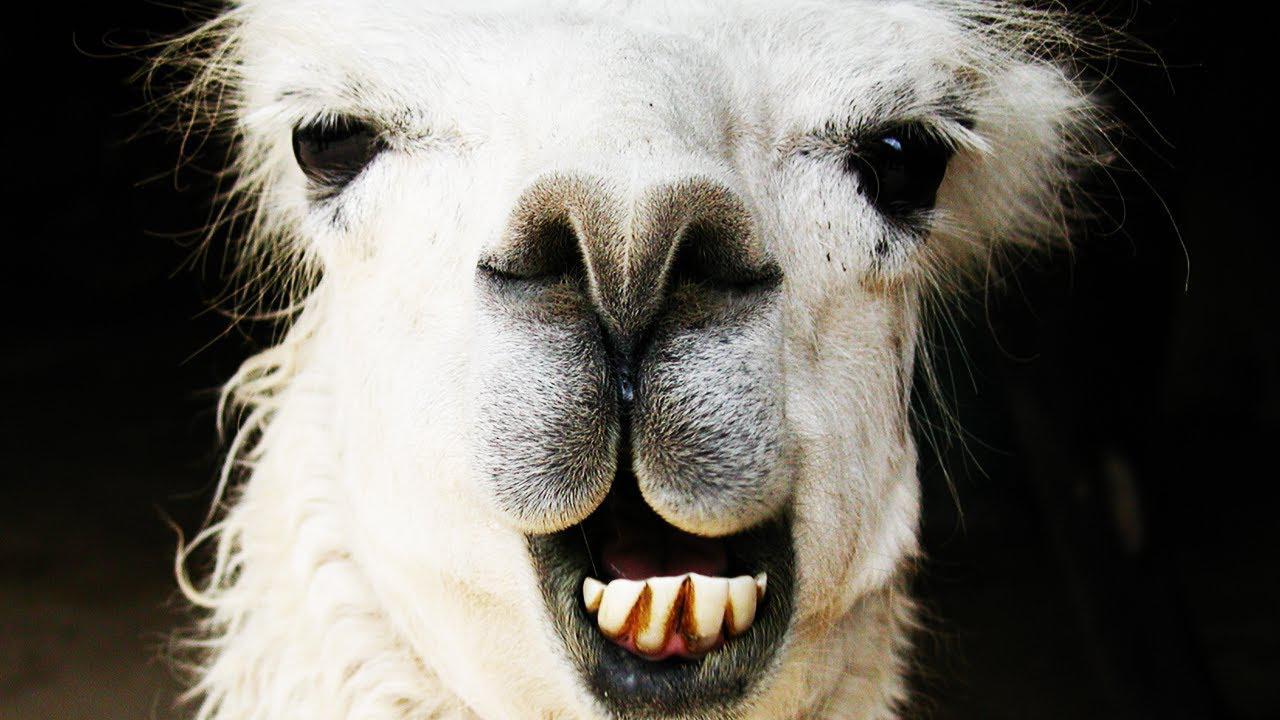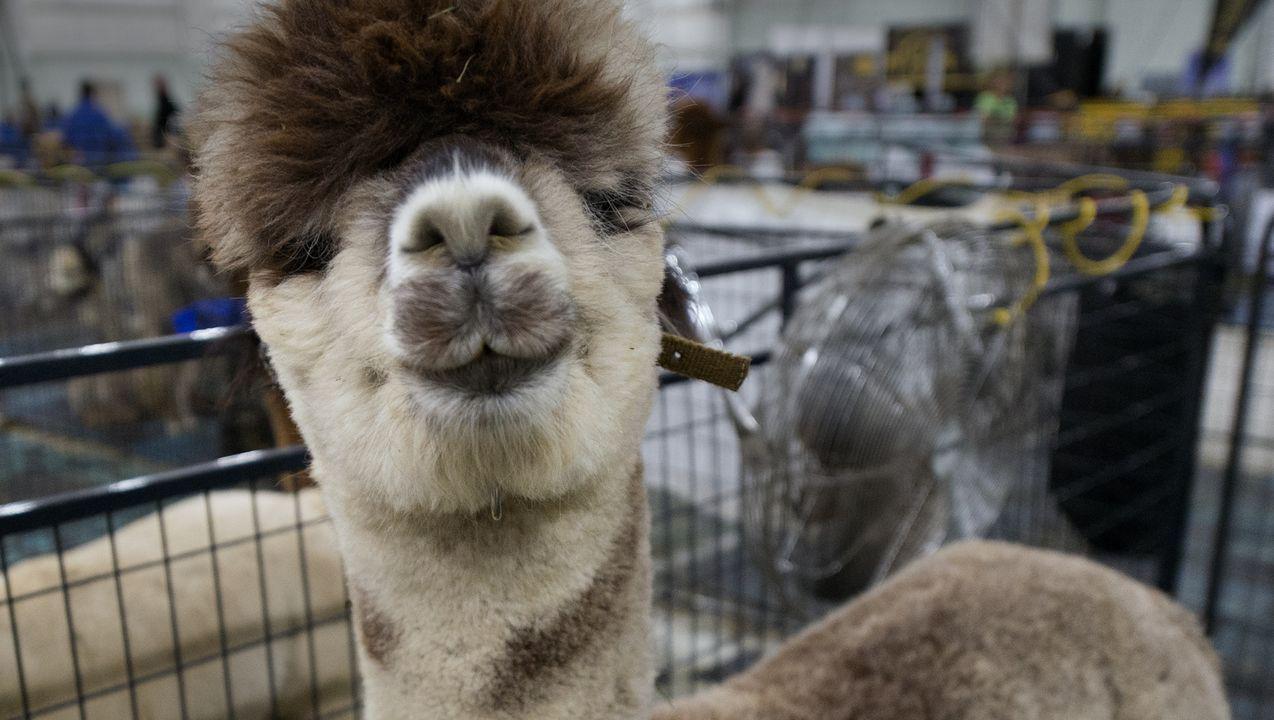The first image is the image on the left, the second image is the image on the right. For the images displayed, is the sentence "There is a young llama in both images." factually correct? Answer yes or no. No. The first image is the image on the left, the second image is the image on the right. Assess this claim about the two images: "Every llama appears to be looking directly at the viewer (i.e. facing the camera).". Correct or not? Answer yes or no. Yes. 